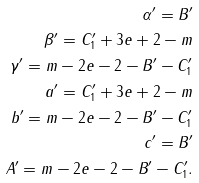Convert formula to latex. <formula><loc_0><loc_0><loc_500><loc_500>\alpha ^ { \prime } = B ^ { \prime } \\ \beta ^ { \prime } = C ^ { \prime } _ { 1 } + 3 e + 2 - m \\ \gamma ^ { \prime } = m - 2 e - 2 - B ^ { \prime } - C ^ { \prime } _ { 1 } \\ a ^ { \prime } = C ^ { \prime } _ { 1 } + 3 e + 2 - m \\ b ^ { \prime } = m - 2 e - 2 - B ^ { \prime } - C ^ { \prime } _ { 1 } \\ c ^ { \prime } = B ^ { \prime } \\ A ^ { \prime } = m - 2 e - 2 - B ^ { \prime } - C ^ { \prime } _ { 1 } .</formula> 